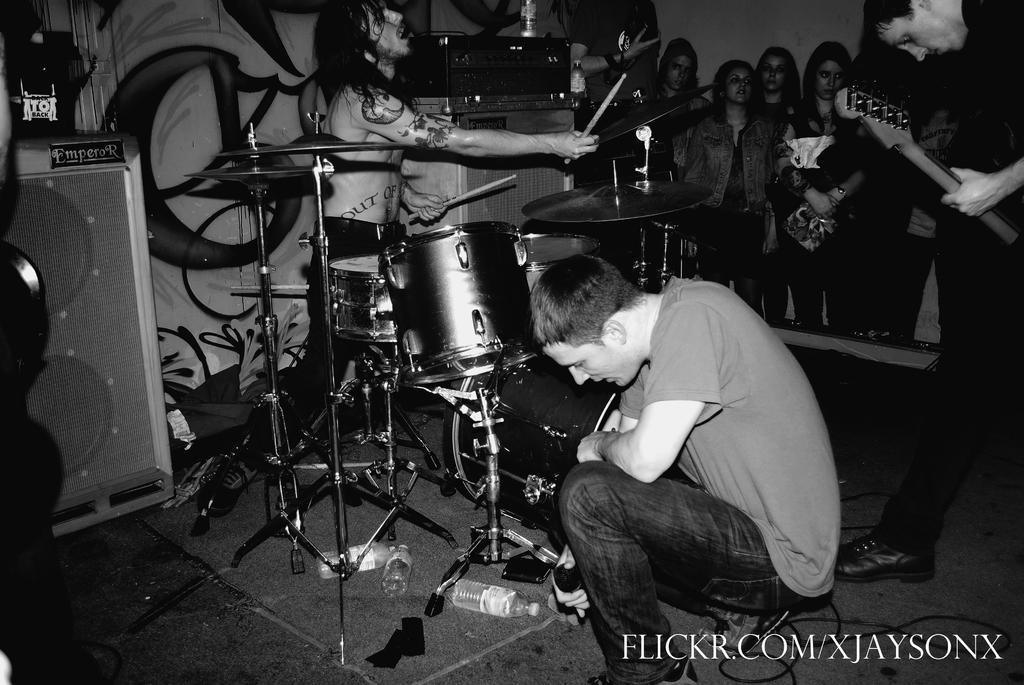Could you give a brief overview of what you see in this image? In the image we can see there is a person who is sitting on the ground and there is a drum set where a man is playing it and people are standing and watching a man who is holding guitar in his hand and the image is in black and white colour. 